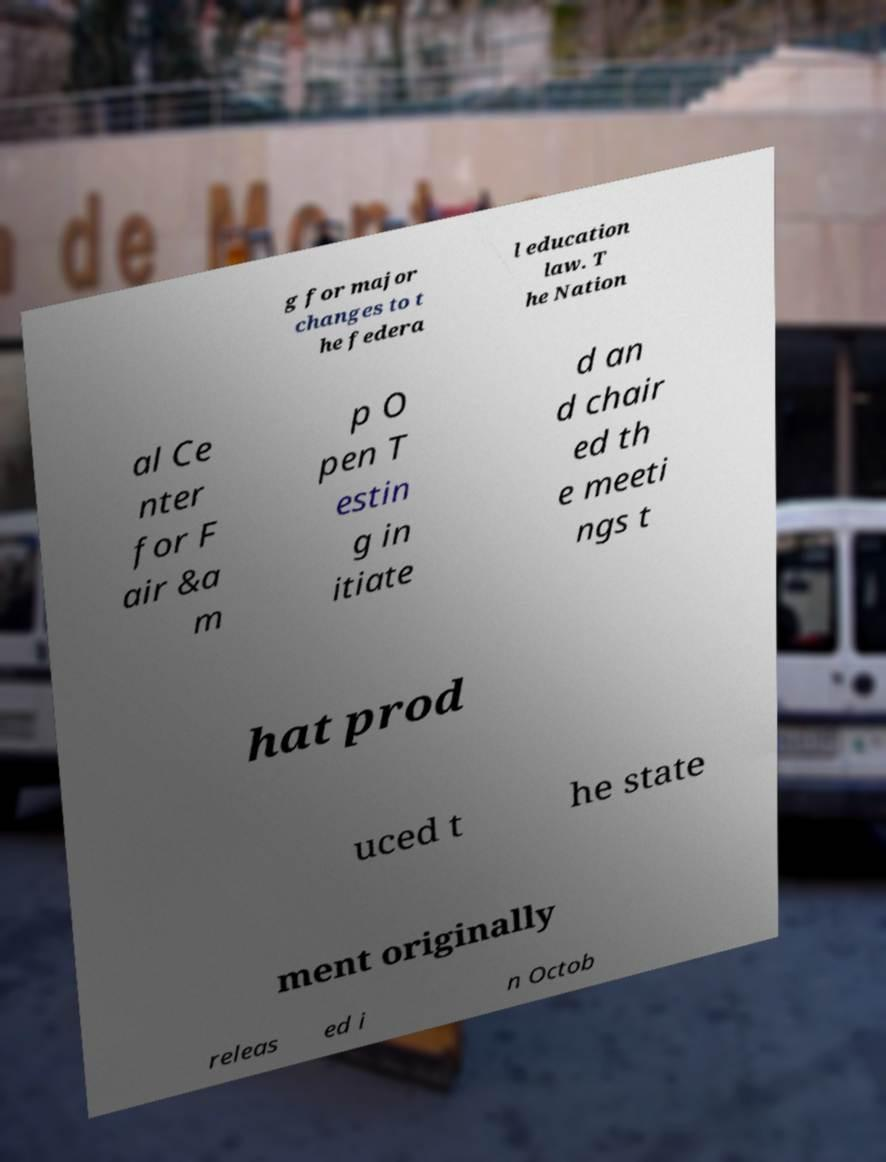Can you read and provide the text displayed in the image?This photo seems to have some interesting text. Can you extract and type it out for me? g for major changes to t he federa l education law. T he Nation al Ce nter for F air &a m p O pen T estin g in itiate d an d chair ed th e meeti ngs t hat prod uced t he state ment originally releas ed i n Octob 